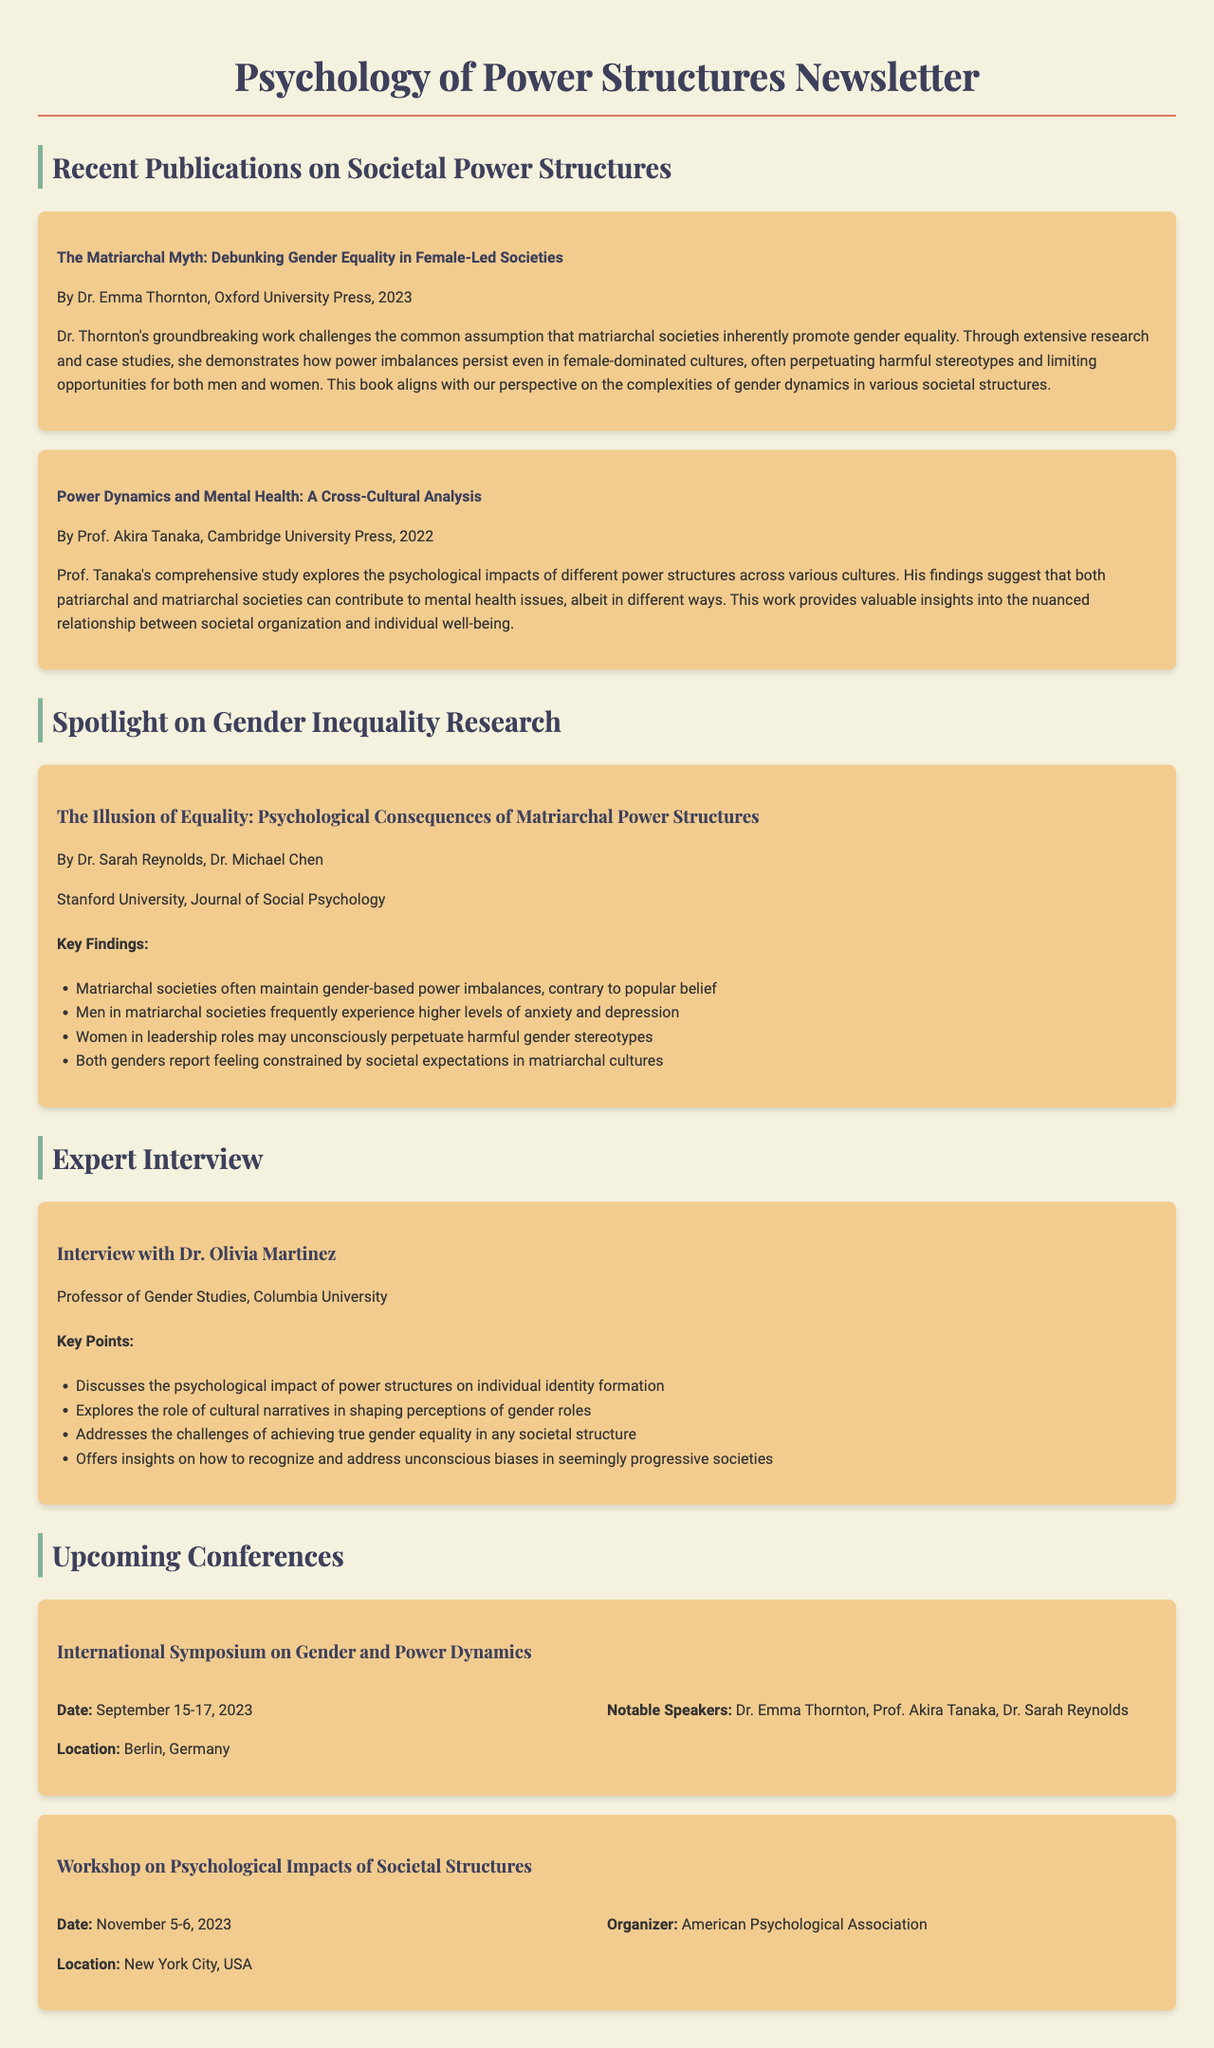what is the title of Dr. Emma Thornton's book? The title is mentioned in the book review section, detailing Dr. Thornton's work on gender equality in matriarchal societies.
Answer: The Matriarchal Myth: Debunking Gender Equality in Female-Led Societies who is the author of the featured study? The featured study lists the authors at the top of the section, including Dr. Sarah Reynolds and Dr. Michael Chen.
Answer: Dr. Sarah Reynolds, Dr. Michael Chen what year was "Power Dynamics and Mental Health: A Cross-Cultural Analysis" published? The publication year is included in the book review section for Prof. Tanaka's work.
Answer: 2022 what is the publication outlet for the featured study? The publication outlet is provided in the featured study section, indicating where the study was published.
Answer: Journal of Social Psychology how many key findings are listed in the featured study? The number of key findings can be counted from the list provided in the featured study section.
Answer: Four who will be speaking at the International Symposium on Gender and Power Dynamics? Key speakers are detailed in the upcoming conferences section, providing names of the notable speakers.
Answer: Dr. Emma Thornton, Prof. Akira Tanaka, Dr. Sarah Reynolds what is discussed in the expert interview? The key points of the interview highlight specific themes addressed by Dr. Olivia Martinez regarding societal structures.
Answer: Psychological impact of power structures on individual identity formation when is the Workshop on Psychological Impacts of Societal Structures scheduled? The date is provided in the upcoming conferences section, indicating when the workshop will take place.
Answer: November 5-6, 2023 